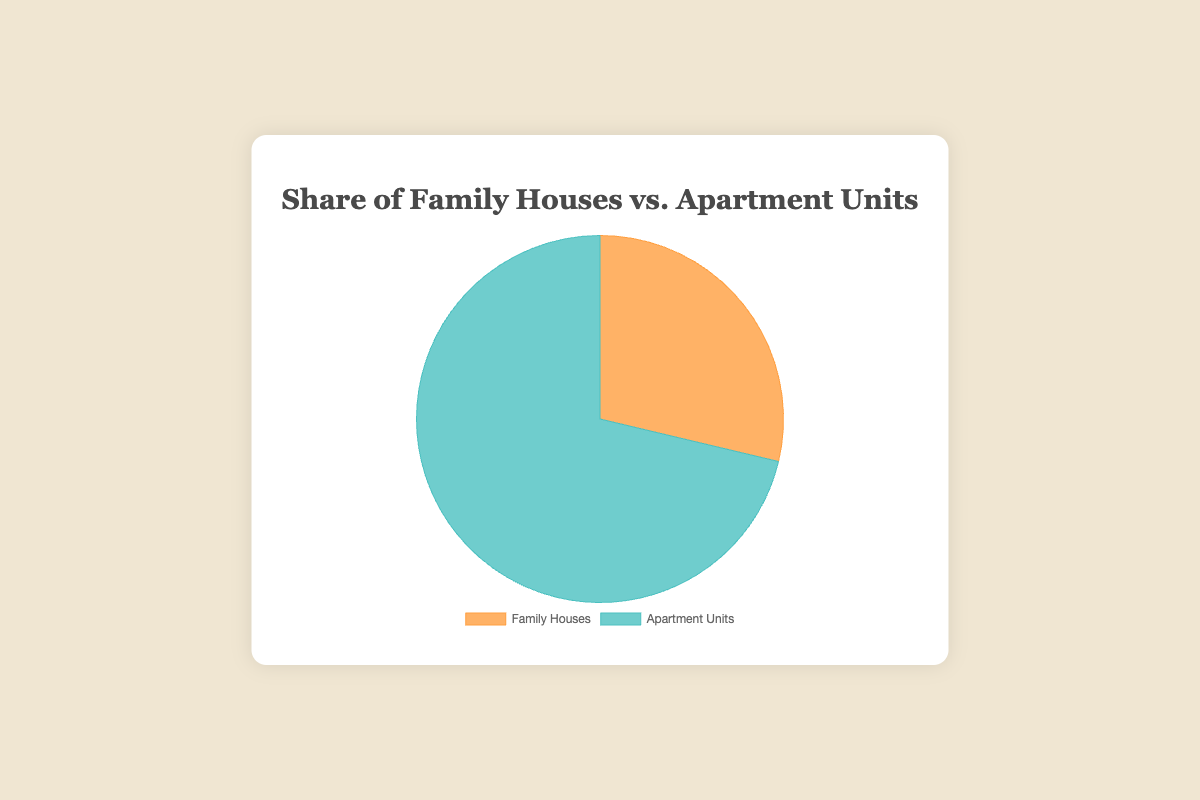What's the total number of family house units? Sum the units of all family houses: Greenwood (34) + Riverside Estates (28) + Woodland Meadows (45) + Maple Grove (32), which equals 139 units.
Answer: 139 Which property type has more units, family houses or apartment units? Compare the total units of family houses (139) to apartment units (345). Apartment units have more units.
Answer: Apartment units What's the percentage of apartment units in the total portfolio? Calculate the total units: 139 (family houses) + 345 (apartment units) = 484. Then calculate the percentage: (345/484) * 100 ≈ 71.28%.
Answer: 71.28% How many more apartment units are there than family houses? Subtract family house units (139) from apartment units (345): 345 - 139 = 206.
Answer: 206 If another 50 family house units were added, what would be the new percentage of family houses? Add 50 to the existing family house units: 139 + 50 = 189. The new total units: 189 (family houses) + 345 (apartment units) = 534. Calculate the percentage: (189/534) * 100 ≈ 35.39%.
Answer: 35.39% What is the proportion of the two property types in simplest form? Find the greatest common divisor (GCD) of 139 (family houses) and 345 (apartment units), which is 1. Thus, the simplest form is 139:345.
Answer: 139:345 What color represents family houses in the pie chart? Visually identify that the segment representing family houses is colored in an orange hue.
Answer: Orange What color represents apartment units in the pie chart? Visually identify that the segment representing apartment units is colored in a teal hue.
Answer: Teal What's the difference in percentage points between the share of family houses and apartment units? Calculate the percentage of family houses: (139/484) * 100 ≈ 28.72%. Difference in percentage points: 71.28% (apartments) - 28.72% (family houses) = 42.56 percentage points.
Answer: 42.56 What is the sum of units in Sunset Apartments and City View Plaza? Sum the units: Sunset Apartments (90) + City View Plaza (100) = 190 units.
Answer: 190 